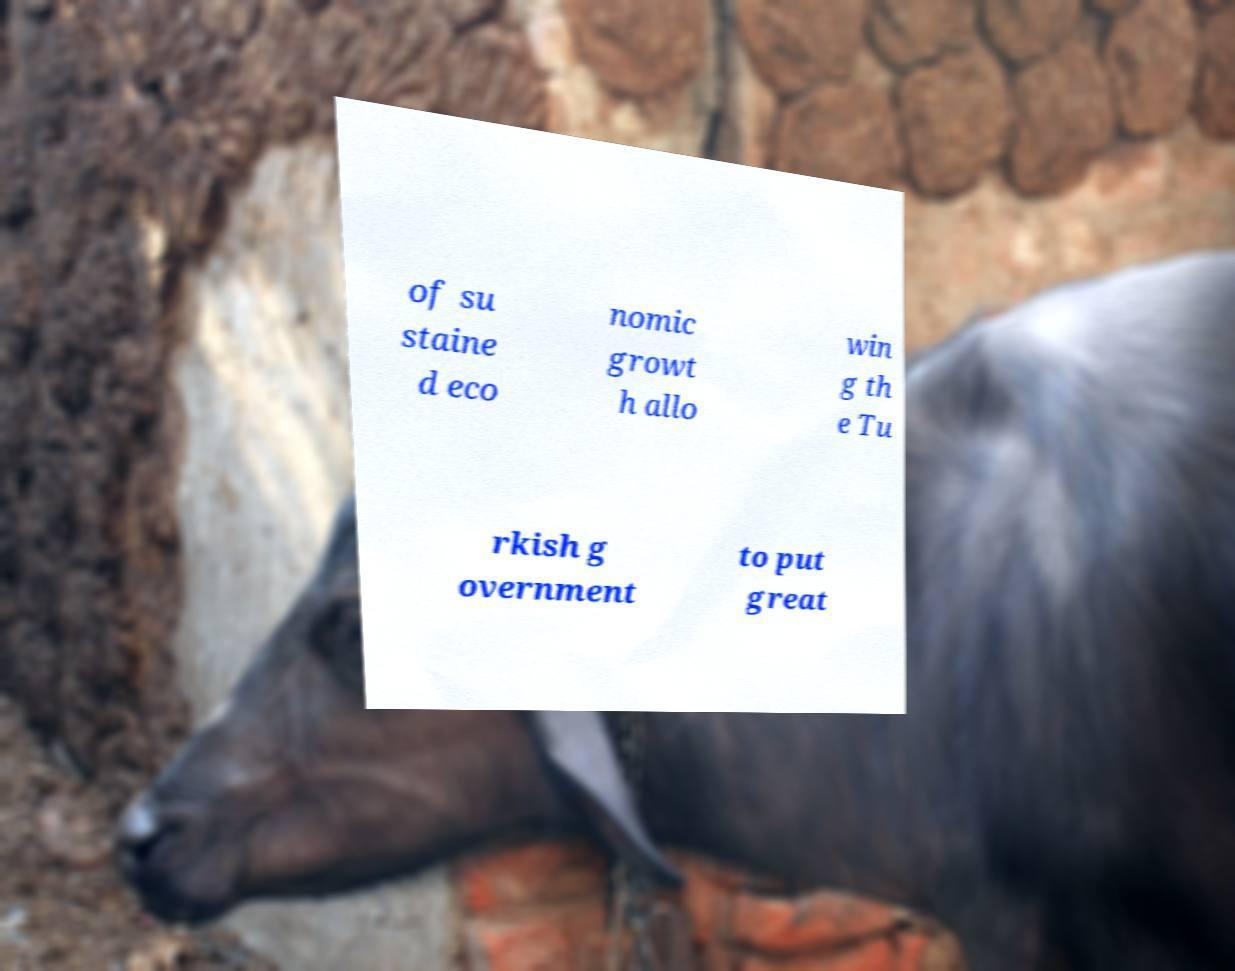Please read and relay the text visible in this image. What does it say? of su staine d eco nomic growt h allo win g th e Tu rkish g overnment to put great 